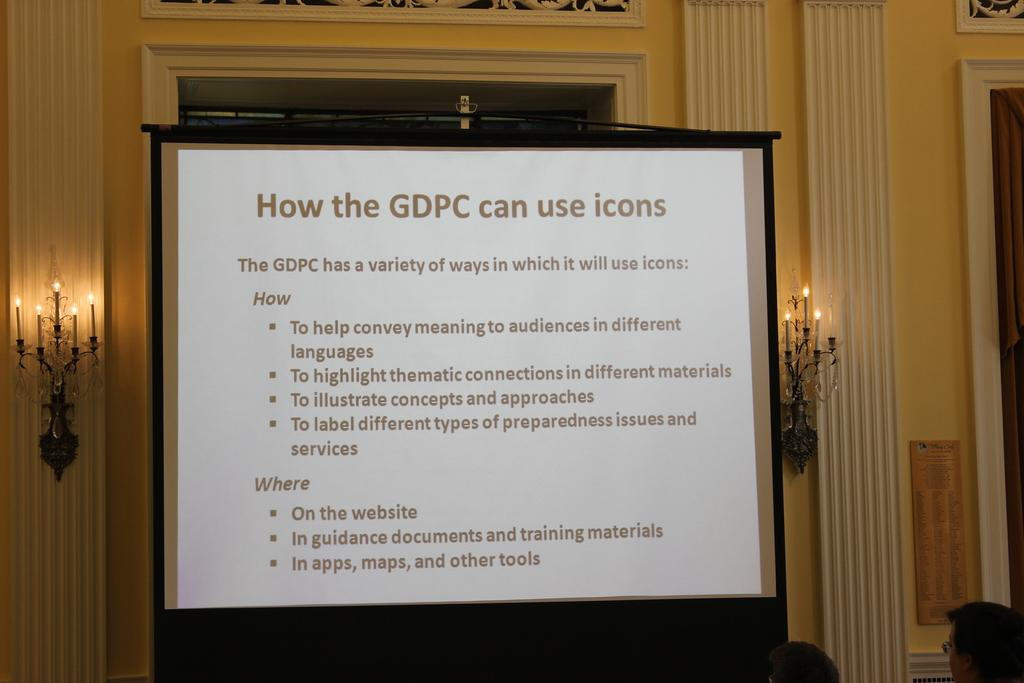What is the main subject of the picture? The main subject of the picture is a projected image. Where are the two persons located in the image? The two persons are in the right corner of the image. What else can be seen in the background of the image? There are other objects in the background of the image. What type of beds are visible in the image? There are no beds present in the image. What emotion might the two persons be feeling in the image? The image does not provide any information about the emotions of the two persons, so it cannot be determined from the image. 